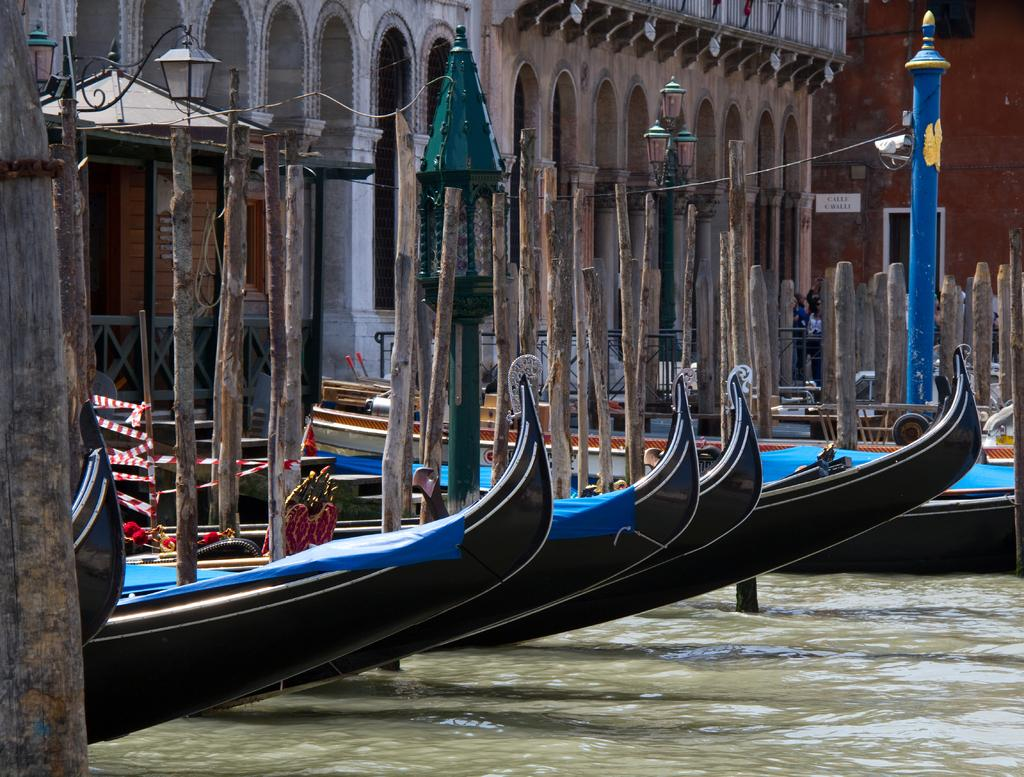What is the main feature of the image? The main feature of the image is water. What is on the water in the image? There are boats on the water in the image. What can be seen behind the boats? There are buildings behind the boats in the image. What is located to the left of the image? There are street light poles and a wooden railing to the left of the image. Where is the bee flying in the image? There is no bee present in the image. Which direction is north in the image? The image does not provide any information about the direction of north. 